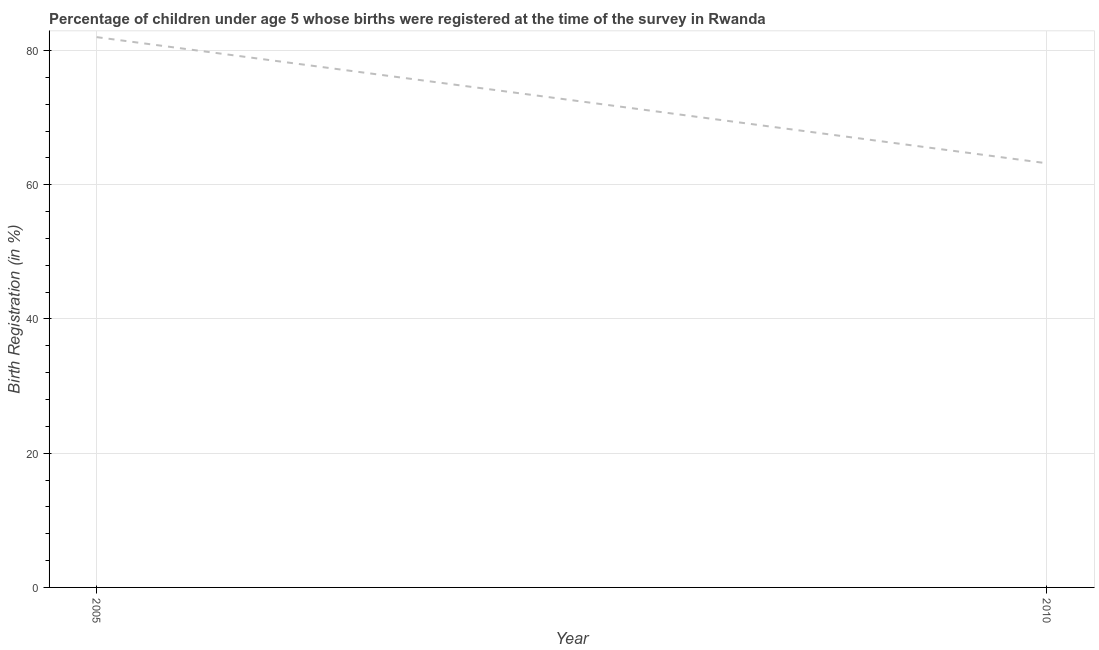What is the birth registration in 2010?
Offer a very short reply. 63.2. Across all years, what is the minimum birth registration?
Provide a succinct answer. 63.2. What is the sum of the birth registration?
Offer a very short reply. 145.2. What is the difference between the birth registration in 2005 and 2010?
Keep it short and to the point. 18.8. What is the average birth registration per year?
Keep it short and to the point. 72.6. What is the median birth registration?
Provide a short and direct response. 72.6. What is the ratio of the birth registration in 2005 to that in 2010?
Your answer should be compact. 1.3. How many lines are there?
Your response must be concise. 1. How many years are there in the graph?
Provide a short and direct response. 2. What is the difference between two consecutive major ticks on the Y-axis?
Keep it short and to the point. 20. Are the values on the major ticks of Y-axis written in scientific E-notation?
Your response must be concise. No. Does the graph contain grids?
Provide a succinct answer. Yes. What is the title of the graph?
Offer a terse response. Percentage of children under age 5 whose births were registered at the time of the survey in Rwanda. What is the label or title of the Y-axis?
Make the answer very short. Birth Registration (in %). What is the Birth Registration (in %) in 2005?
Ensure brevity in your answer.  82. What is the Birth Registration (in %) in 2010?
Make the answer very short. 63.2. What is the ratio of the Birth Registration (in %) in 2005 to that in 2010?
Offer a terse response. 1.3. 